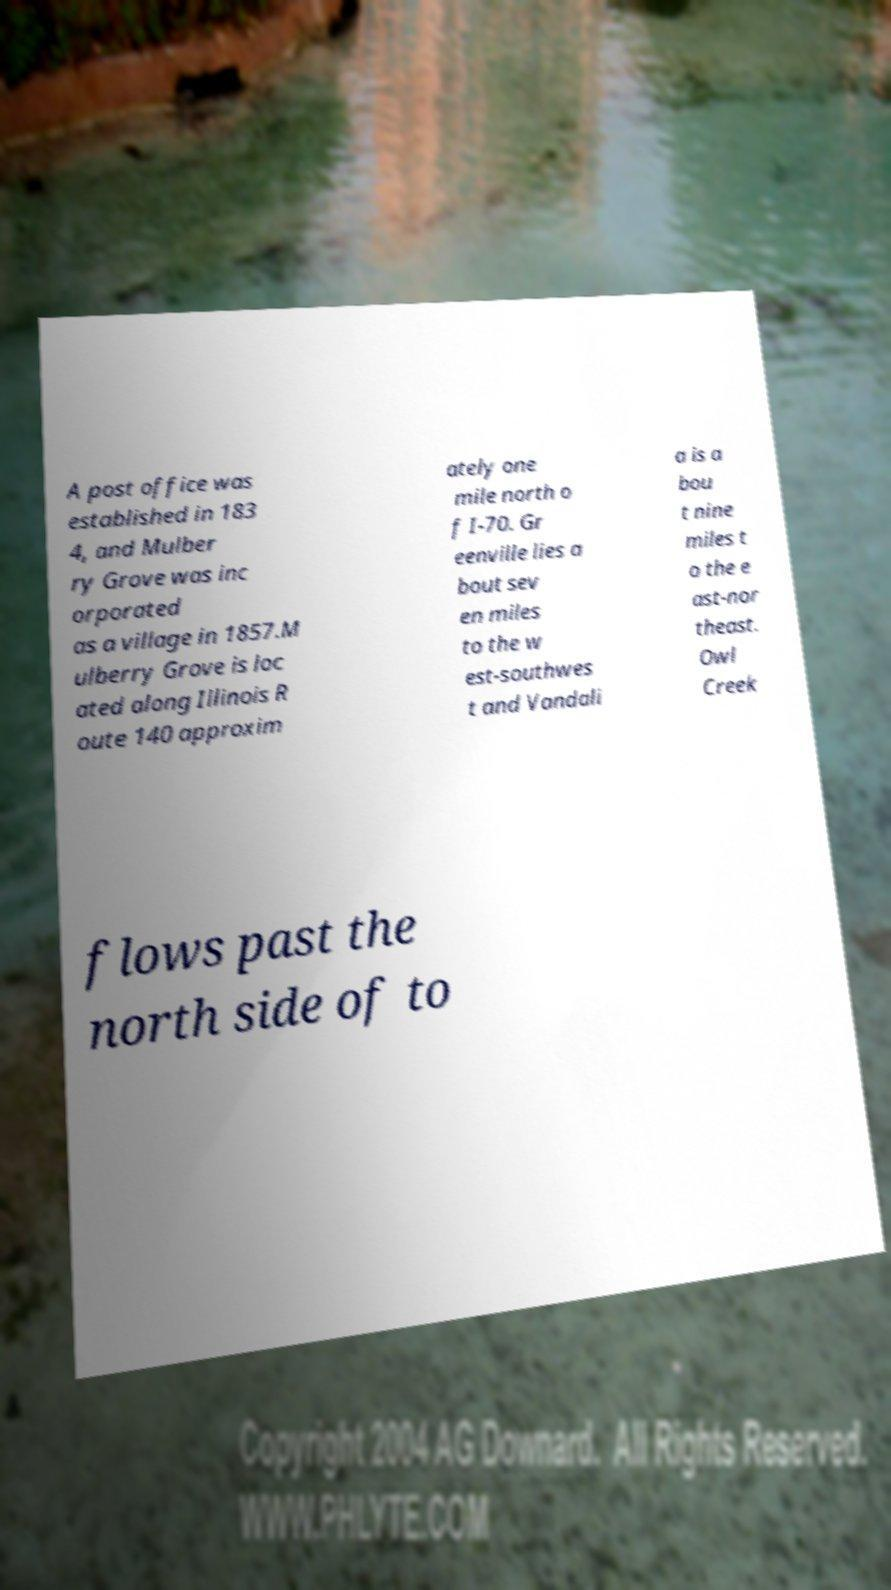Could you assist in decoding the text presented in this image and type it out clearly? A post office was established in 183 4, and Mulber ry Grove was inc orporated as a village in 1857.M ulberry Grove is loc ated along Illinois R oute 140 approxim ately one mile north o f I-70. Gr eenville lies a bout sev en miles to the w est-southwes t and Vandali a is a bou t nine miles t o the e ast-nor theast. Owl Creek flows past the north side of to 